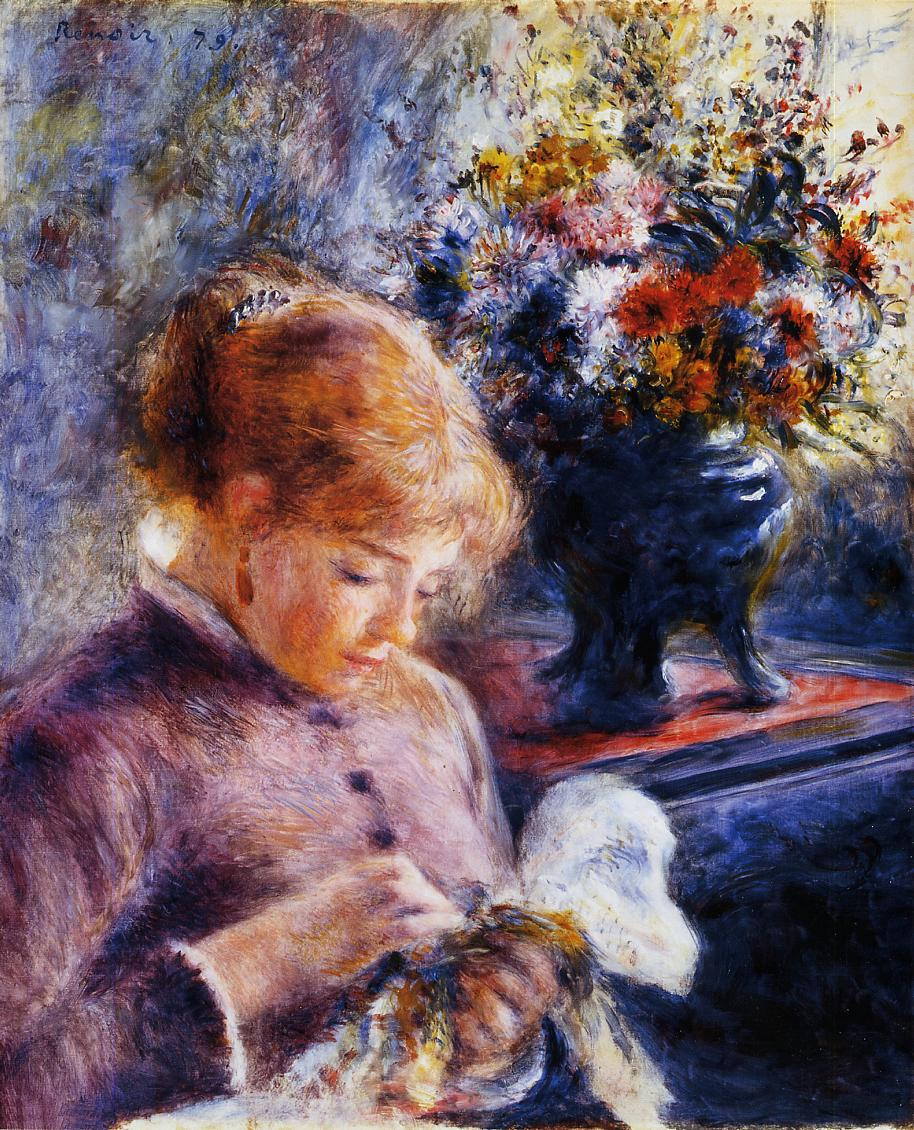Describe the scene as if it were part of a detective novel. The young woman sat at the ornate wooden table, her fingers deftly working the delicate fabric with a needle. Around her, the room was bathed in the soft late afternoon light, which cast long shadows against the walls and highlighted the vibrant bouquet resting in the dark vase. It was a silent and serene setting, yet a subtle air of tension lingered. What secrets did this tranquil scene hold? Her expression, calm yet pensive, suggested she was lost in thought—perhaps pondering more than just her needlework. Could she be embroidering coded messages into the cloth? Outside, the sounds of the city grew faint, and the detective knew it was only a matter of time before the tranquility would be shattered by an unexpected turn of events... The detective entered quietly, not wanting to disrupt the serenity but keenly aware that this moment of peace could hold a vital clue. As he stepped further into the room, the detective's eyes scanned the scene with meticulous care. Every detail mattered. The soft rustling of the woman's dress as she adjusted herself, the faint fragrance of the flowers mixing with the musty smell of old books lining the shelves, the fleeting look of startlement that flashed across her face when she noticed him—all these elements formed a tapestry of potential evidence. Approaching the table, he couldn't help but wonder about the enigmatic pattern she embroidered. Was it simply the intricate design of a dedicated seamstress, or the calculated handiwork of someone deeply entangled in a web of mystery? He bent closer, examining her work, knowing that within these threads lay the answers he sought. 